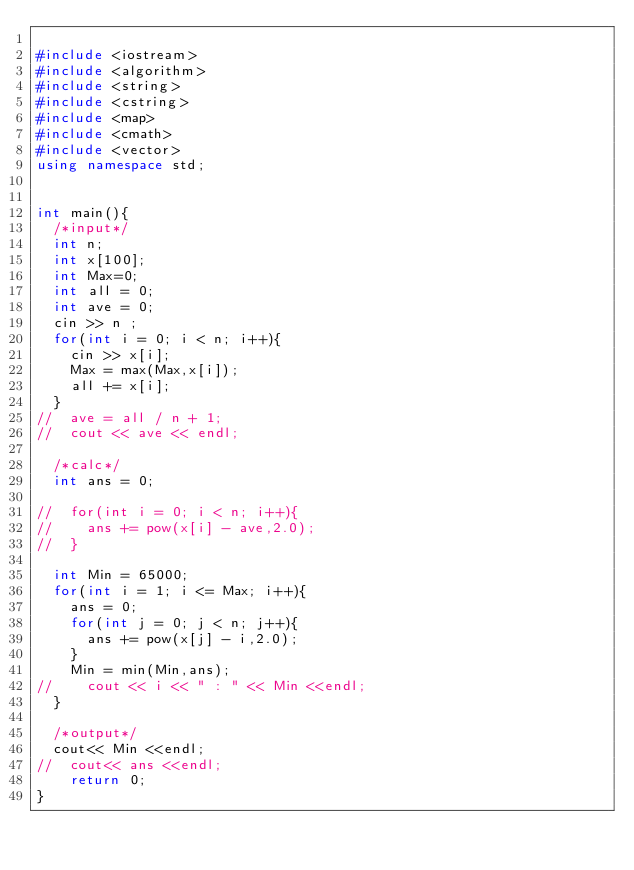Convert code to text. <code><loc_0><loc_0><loc_500><loc_500><_C++_>
#include <iostream>
#include <algorithm>
#include <string>
#include <cstring>
#include <map>
#include <cmath>
#include <vector>
using namespace std;


int main(){
	/*input*/
	int n;
	int x[100];
	int Max=0;
	int all = 0;
	int ave = 0;
	cin >> n ;
	for(int i = 0; i < n; i++){
		cin >> x[i];
		Max = max(Max,x[i]);
		all += x[i];
	}
//	ave = all / n + 1;
//	cout << ave << endl;

	/*calc*/
	int ans = 0;

//	for(int i = 0; i < n; i++){
//		ans += pow(x[i] - ave,2.0);
//	}

	int Min = 65000;
	for(int i = 1; i <= Max; i++){
		ans = 0;
		for(int j = 0; j < n; j++){
			ans += pow(x[j] - i,2.0);
		}
		Min = min(Min,ans);
//		cout << i << " : " << Min <<endl;
	}

	/*output*/
	cout<< Min <<endl;
//	cout<< ans <<endl;
    return 0;
}
</code> 